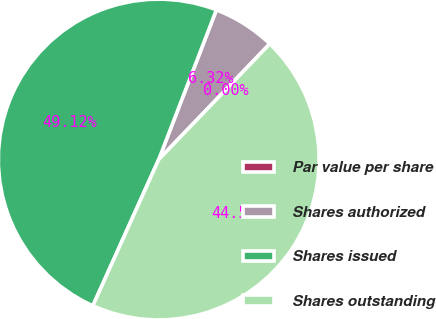<chart> <loc_0><loc_0><loc_500><loc_500><pie_chart><fcel>Par value per share<fcel>Shares authorized<fcel>Shares issued<fcel>Shares outstanding<nl><fcel>0.0%<fcel>6.32%<fcel>49.12%<fcel>44.56%<nl></chart> 